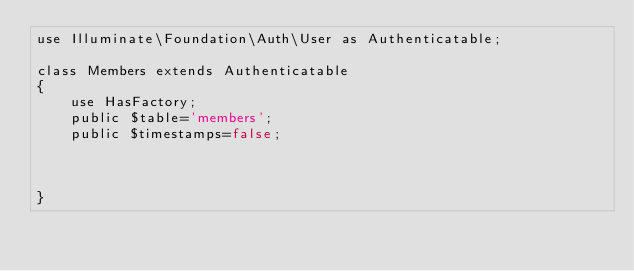<code> <loc_0><loc_0><loc_500><loc_500><_PHP_>use Illuminate\Foundation\Auth\User as Authenticatable;

class Members extends Authenticatable
{
    use HasFactory;
    public $table='members';
    public $timestamps=false;


    
}
</code> 